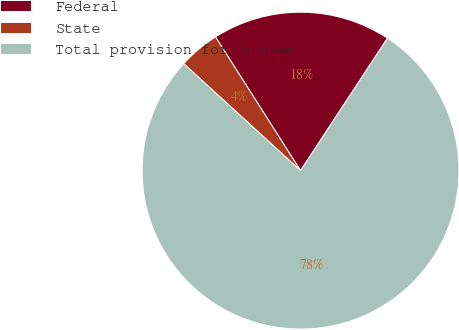Convert chart to OTSL. <chart><loc_0><loc_0><loc_500><loc_500><pie_chart><fcel>Federal<fcel>State<fcel>Total provision for income<nl><fcel>18.26%<fcel>4.19%<fcel>77.54%<nl></chart> 